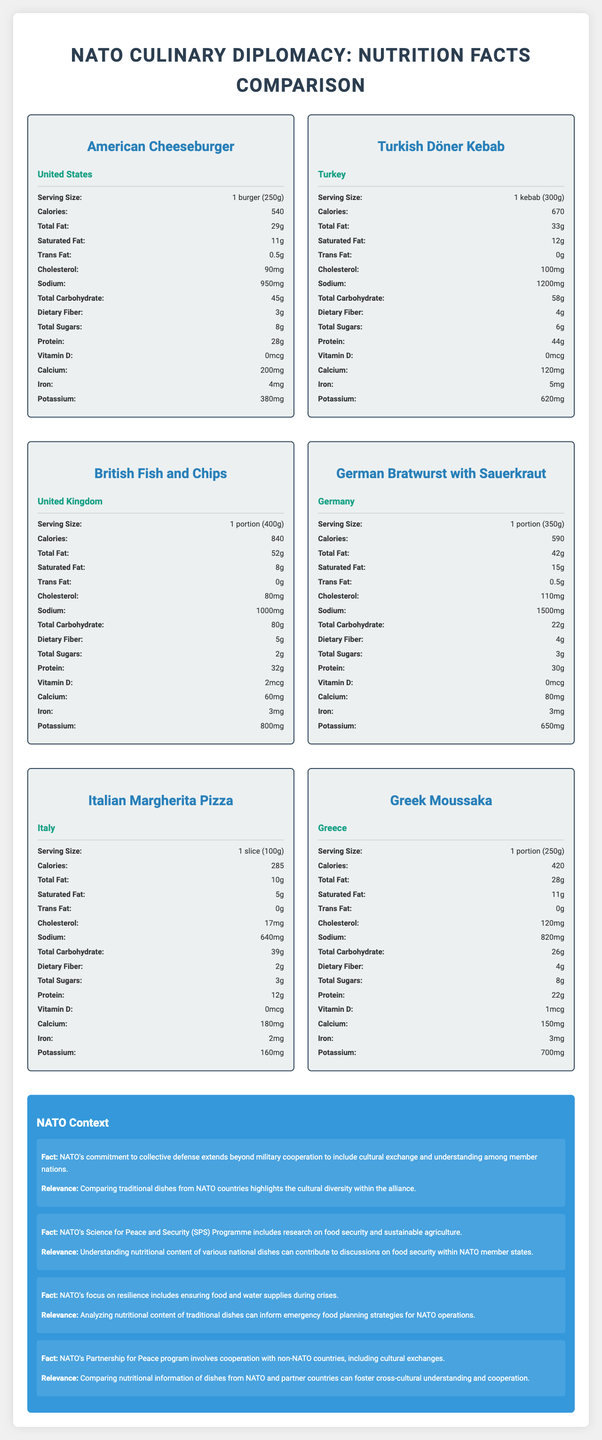which dish has the highest protein content? The Turkish Döner Kebab has 44g of protein, which is higher than any other dish in the comparisons.
Answer: Turkish Döner Kebab which dish has the lowest sodium content? The Italian Margherita Pizza has 640mg of sodium, which is the lowest among the compared dishes.
Answer: Italian Margherita Pizza how many calories does the British Fish and Chips have? The British Fish and Chips have 840 calories as stated in the nutrition label.
Answer: 840 calories which dish is highest in saturated fat? A. American Cheeseburger B. British Fish and Chips C. German Bratwurst with Sauerkraut D. Greek Moussaka The German Bratwurst with Sauerkraut has 15g of saturated fat, the highest among the listed options.
Answer: C how much dietary fiber does the Greek Moussaka contain? According to the nutrition label, the Greek Moussaka contains 4g of dietary fiber.
Answer: 4g which dish has the highest sodium content? A. American Cheeseburger B. Turkish Döner Kebab C. British Fish and Chips D. German Bratwurst with Sauerkraut The German Bratwurst with Sauerkraut has 1500mg of sodium, the highest among the listed options.
Answer: D is there any dish that contains trans fat? Both the American Cheeseburger and German Bratwurst with Sauerkraut contain trans fat (0.5g each).
Answer: Yes how much iron does the Turkish Döner Kebab provide? The nutrition label indicates that the Turkish Döner Kebab provides 5mg of iron.
Answer: 5mg describe the main idea of the document. The document presents side-by-side comparisons of the nutritional content of traditional dishes such as the American Cheeseburger, Turkish Döner Kebab, British Fish and Chips, German Bratwurst with Sauerkraut, Italian Margherita Pizza, and Greek Moussaka. It also explains how these comparisons can benefit NATO's goals related to cultural understanding, food security, and emergency planning.
Answer: The document compares the nutritional facts of traditional dishes from various NATO member countries and contextualizes the importance of understanding these nutritional profiles within the broader framework of NATO's cultural and food security initiatives. which dish has the highest calcium content? The American Cheeseburger has 200mg of calcium, which is the highest among the compared dishes.
Answer: American Cheeseburger what is the serving size of the Greek Moussaka? The nutrition label states that the serving size of the Greek Moussaka is 1 portion, equivalent to 250g.
Answer: 1 portion (250g) which dish has the lowest total carbohydrate content? The German Bratwurst with Sauerkraut has 22g of total carbohydrates, the lowest among the compared dishes.
Answer: German Bratwurst with Sauerkraut how much cholesterol does the Italian Margherita Pizza have? The Italian Margherita Pizza contains 17mg of cholesterol as mentioned on the nutrition label.
Answer: 17mg is the vitamin D content available for all dishes? Only British Fish and Chips and Greek Moussaka have a listed vitamin D content.
Answer: No which dish has the most calories? The British Fish and Chips has 840 calories, which is higher than any other dish listed.
Answer: British Fish and Chips what are the dietary implications of high sodium intake listed in NATO context? The document does not provide specifics on the dietary implications of high sodium intake in the NATO context.
Answer: Not enough information which dish has the highest total sugars? The Greek Moussaka has 8g of total sugars, which is the highest among all dishes compared.
Answer: Greek Moussaka how does NATO's commitment to cultural exchange relate to this document? One of the NATO context facts mentions that NATO's commitment to collective defense includes cultural exchange, and comparing traditional dishes illustrates the cultural diversity and helps foster understanding among member nations.
Answer: Comparing nutritional information of dishes from NATO countries highlights the cultural diversity within the alliance. 